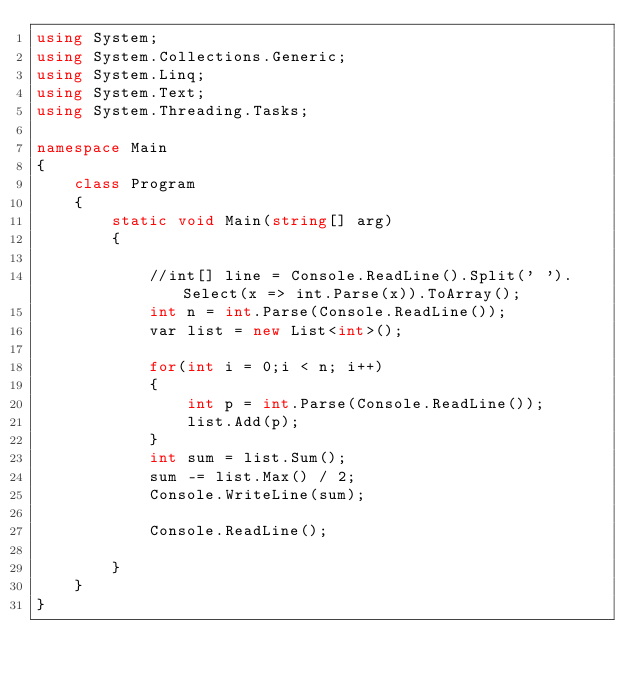Convert code to text. <code><loc_0><loc_0><loc_500><loc_500><_C#_>using System;
using System.Collections.Generic;
using System.Linq;
using System.Text;
using System.Threading.Tasks;

namespace Main
{
    class Program
    {
        static void Main(string[] arg)
        {

            //int[] line = Console.ReadLine().Split(' ').Select(x => int.Parse(x)).ToArray();
            int n = int.Parse(Console.ReadLine());
            var list = new List<int>();

            for(int i = 0;i < n; i++)
            {
                int p = int.Parse(Console.ReadLine());
                list.Add(p);
            }
            int sum = list.Sum();
            sum -= list.Max() / 2;
            Console.WriteLine(sum);

            Console.ReadLine();

        }
    }
}
</code> 